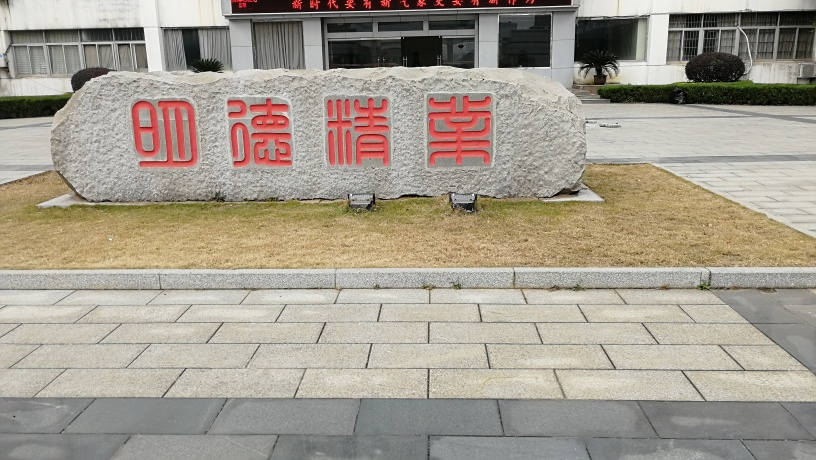Can you describe the object and any text it may have? The object in the image is a large rock or boulder with carved indentations painted red, containing Chinese characters. The characters stand out prominently against the grey stone. The text is not translated here, but it typically denotes a place, idea, or commemoration of some kind. 